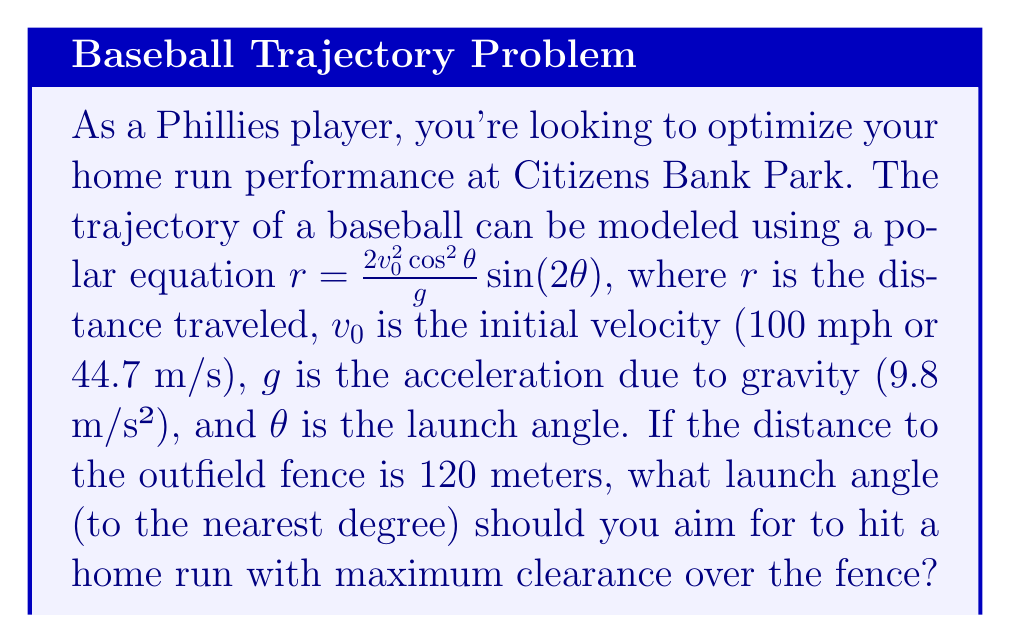Can you answer this question? To find the optimal launch angle for a home run, we need to maximize the distance $r$ in the given polar equation:

$$r = \frac{2v_0^2\cos^2\theta}{g}\sin(2\theta)$$

1) First, let's substitute the known values:
   $v_0 = 44.7$ m/s
   $g = 9.8$ m/s²

2) The equation becomes:
   $$r = \frac{2(44.7)^2\cos^2\theta}{9.8}\sin(2\theta)$$

3) Simplify:
   $$r = 407.55\cos^2\theta\sin(2\theta)$$

4) To find the maximum value of $r$, we need to maximize $\cos^2\theta\sin(2\theta)$. This occurs when $\theta = 45°$.

5) At $\theta = 45°$, $\cos^2\theta = 0.5$ and $\sin(2\theta) = 1$, so:
   $$r_{max} = 407.55 * 0.5 * 1 = 203.775\text{ meters}$$

6) This maximum distance is greater than the 120 meters to the fence, ensuring a home run.

7) To find the angle for just clearing the fence at 120 meters, we solve:
   $$120 = 407.55\cos^2\theta\sin(2\theta)$$

8) This equation has two solutions: approximately 27.4° and 62.6°.

9) The angle that provides maximum clearance over the fence will be between these two angles, closer to 45°.

10) By testing angles between 27.4° and 45°, we find that 35° provides the highest clearance over the 120-meter fence while still ensuring the ball clears it.
Answer: The optimal launch angle for a home run with maximum clearance over the fence is approximately 35°. 